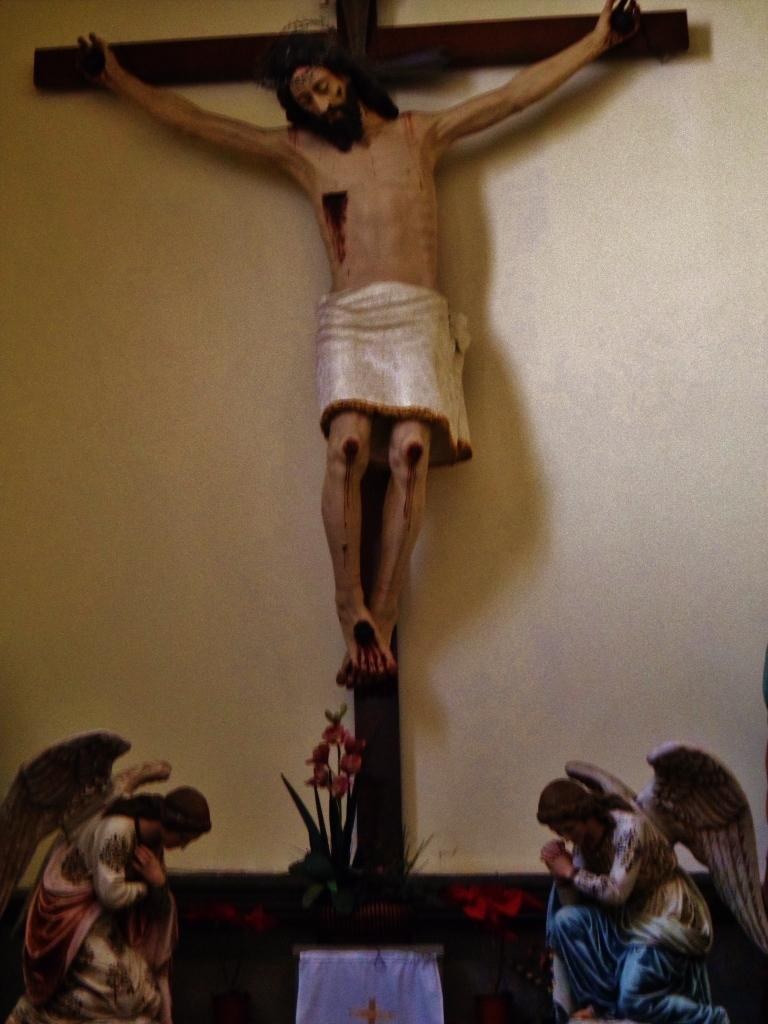What type of art is present in the image? There are sculptures in the image. What can be seen in the background of the image? There is a wall in the background of the image. What type of sticks are used to create the sculptures in the image? There is no information about the materials used to create the sculptures in the image. How does the sculpture make a sound in the image? Sculptures are not capable of making sounds, as they are stationary objects. 